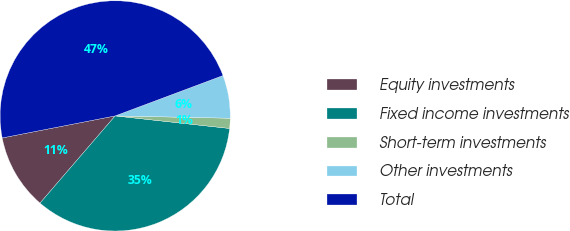Convert chart to OTSL. <chart><loc_0><loc_0><loc_500><loc_500><pie_chart><fcel>Equity investments<fcel>Fixed income investments<fcel>Short-term investments<fcel>Other investments<fcel>Total<nl><fcel>10.61%<fcel>34.58%<fcel>1.42%<fcel>6.02%<fcel>47.37%<nl></chart> 